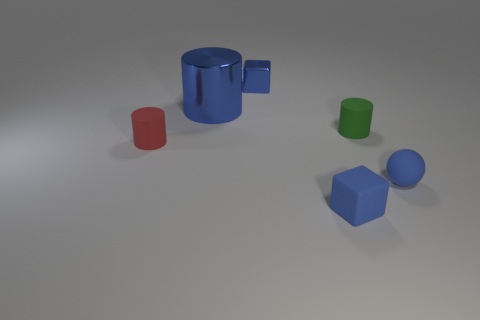Is the number of small red cylinders that are on the left side of the small metallic object the same as the number of tiny matte cylinders that are behind the tiny matte sphere?
Give a very brief answer. No. Is there anything else that is the same size as the rubber ball?
Make the answer very short. Yes. How many blue objects are either big rubber spheres or tiny shiny objects?
Provide a short and direct response. 1. How many blue metal cylinders are the same size as the blue ball?
Give a very brief answer. 0. What color is the cylinder that is both in front of the blue cylinder and left of the tiny green object?
Provide a short and direct response. Red. Are there more small red matte things that are on the right side of the small blue matte sphere than green rubber cylinders?
Offer a terse response. No. Is there a small yellow shiny sphere?
Offer a terse response. No. Is the large metallic cylinder the same color as the metallic block?
Offer a very short reply. Yes. How many large things are either blue metallic objects or blue cylinders?
Your response must be concise. 1. Is there any other thing of the same color as the big metal cylinder?
Offer a very short reply. Yes. 